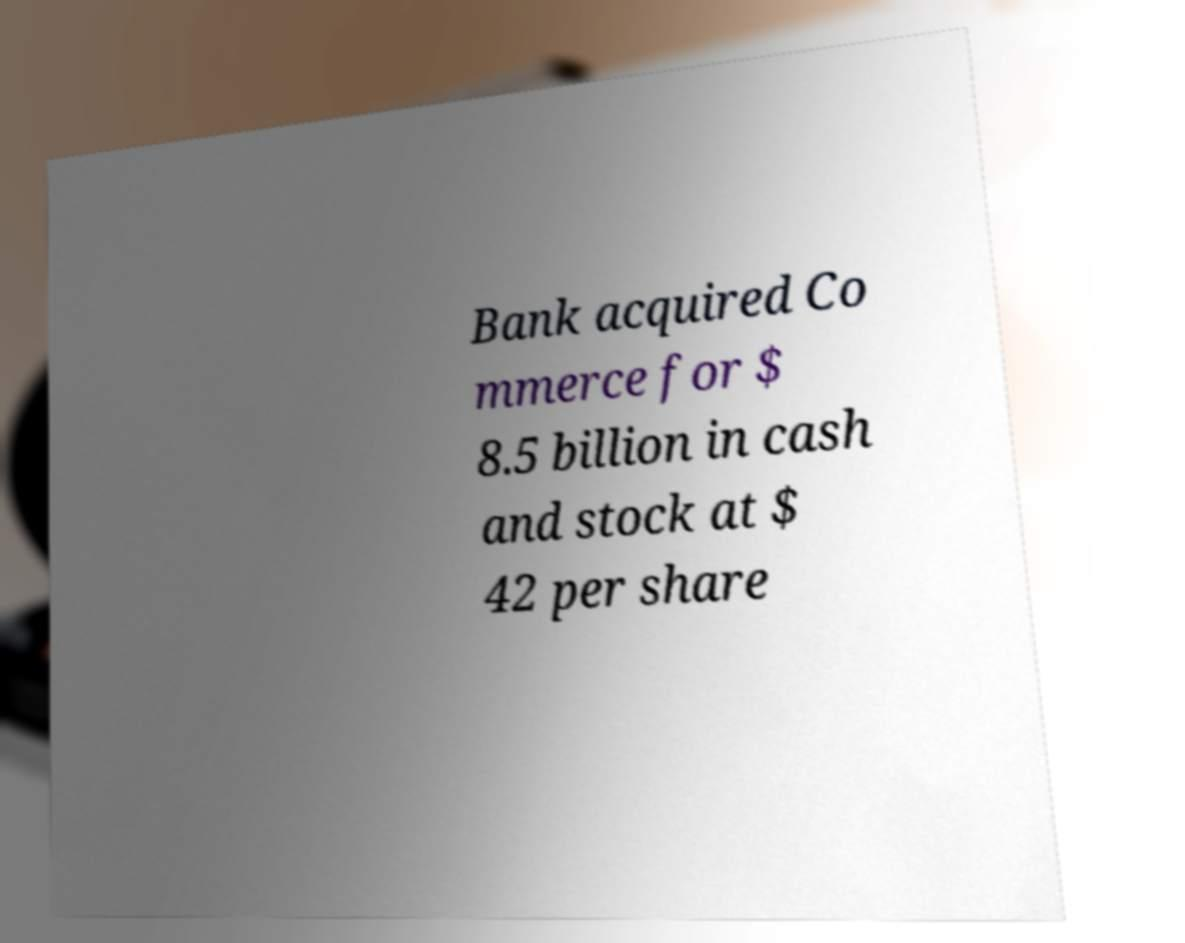There's text embedded in this image that I need extracted. Can you transcribe it verbatim? Bank acquired Co mmerce for $ 8.5 billion in cash and stock at $ 42 per share 